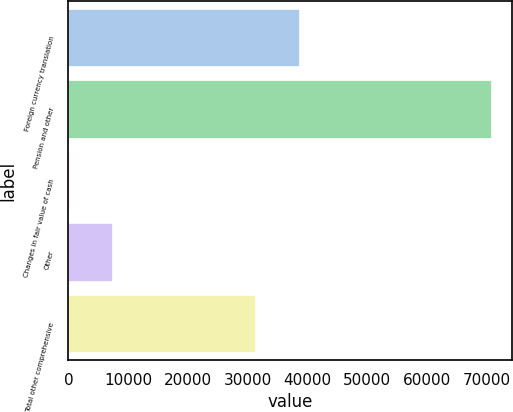<chart> <loc_0><loc_0><loc_500><loc_500><bar_chart><fcel>Foreign currency translation<fcel>Pension and other<fcel>Changes in fair value of cash<fcel>Other<fcel>Total other comprehensive<nl><fcel>38521<fcel>70642<fcel>195<fcel>7239.7<fcel>31234<nl></chart> 